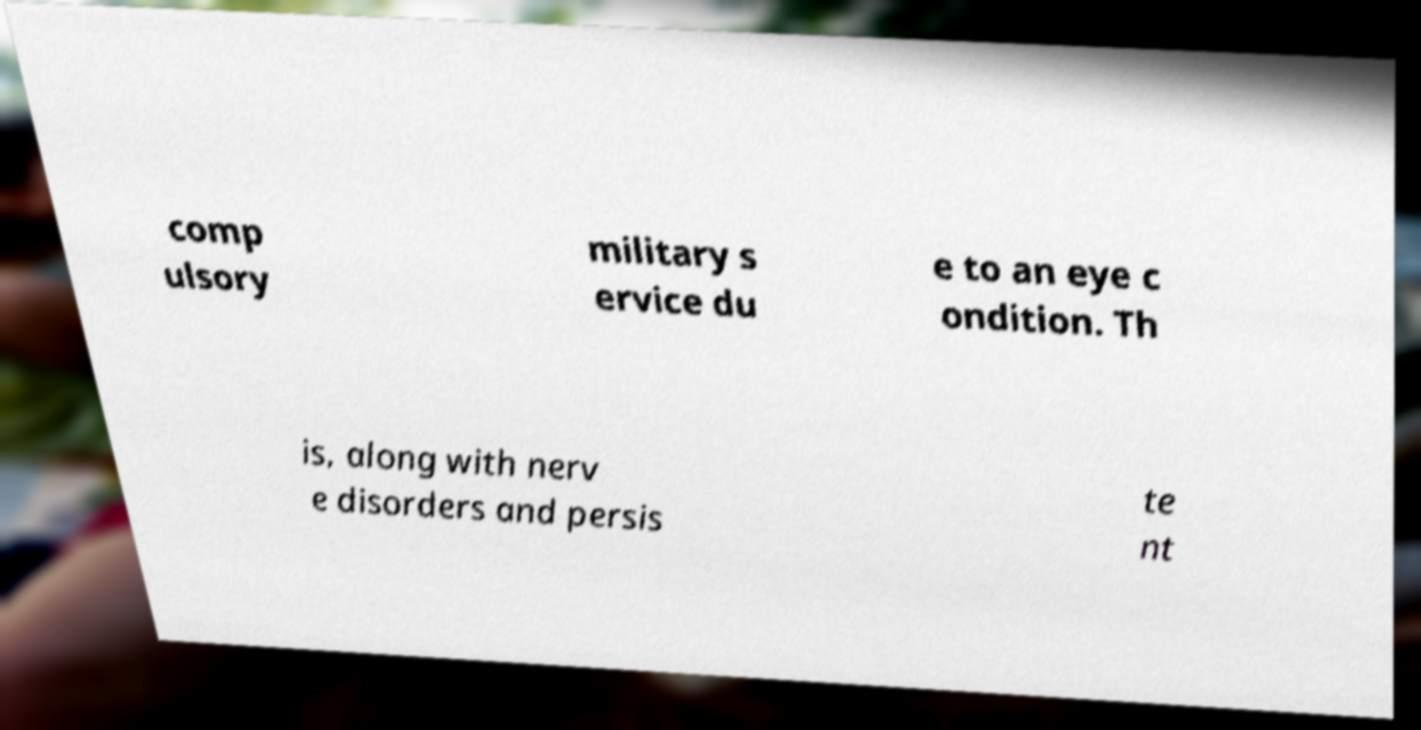I need the written content from this picture converted into text. Can you do that? comp ulsory military s ervice du e to an eye c ondition. Th is, along with nerv e disorders and persis te nt 